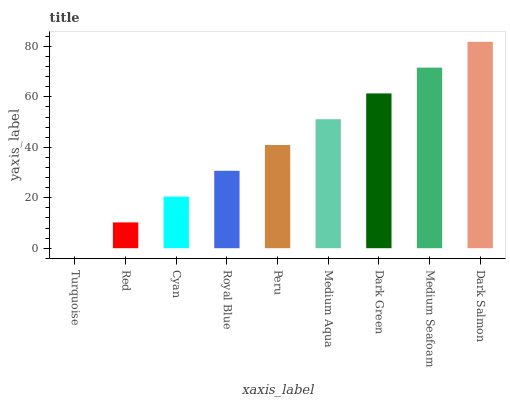Is Turquoise the minimum?
Answer yes or no. Yes. Is Dark Salmon the maximum?
Answer yes or no. Yes. Is Red the minimum?
Answer yes or no. No. Is Red the maximum?
Answer yes or no. No. Is Red greater than Turquoise?
Answer yes or no. Yes. Is Turquoise less than Red?
Answer yes or no. Yes. Is Turquoise greater than Red?
Answer yes or no. No. Is Red less than Turquoise?
Answer yes or no. No. Is Peru the high median?
Answer yes or no. Yes. Is Peru the low median?
Answer yes or no. Yes. Is Turquoise the high median?
Answer yes or no. No. Is Dark Salmon the low median?
Answer yes or no. No. 